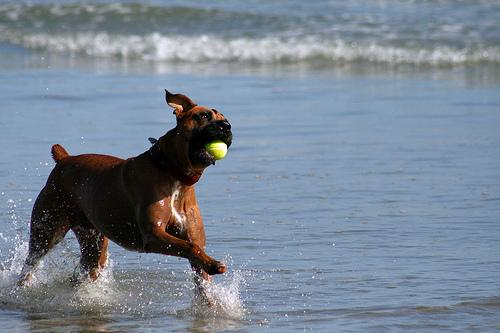Summarize the central visual element and the action taking place in the image. A brown, shorthaired dog is playfully retrieving a bright yellow ball from the water. Briefly describe the main subject and its ongoing action as depicted in the image. A soaked brown dog is running through shallow water, gripping a yellow ball between its teeth. Write a short sentence conveying the primary character and activity in the photo. A dog with a wet, brown coat is in motion in the water, holding a yellow ball in its jaws. Provide a concise description of the primary object in the image and its current activity. A brown dog is running in shallow water with a yellow tennis ball in its mouth. Concisely describe the focal point of the image and their corresponding action. The running brown dog, drenched in water, has a yellow ball gripped firmly in its mouth. Provide a succinct summary of the primary object and its activity in the image. A wet, brown dog is playfully sprinting through water, holding a yellow ball in its mouth. In a brief sentence, express the principal subject and their current action in the image. A soaked, brown dog runs in the water while clutching a yellow tennis ball in its jaws. In one sentence, describe the chief focus and action of the photograph. A brown dog, splashing water as it runs, holds a yellow tennis ball in its mouth. Mention the most significant object in the picture and what it is doing at the moment. The wet brown dog is joyfully running in water, carrying a yellow tennis ball in its mouth. Write a short sentence capturing the main content of the photo. The dog, with a wet brown coat, is fetching a yellow ball while running through water. 